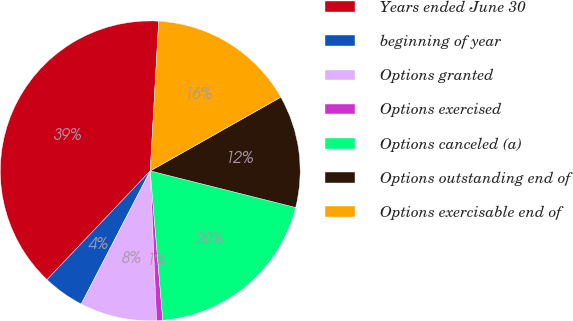Convert chart. <chart><loc_0><loc_0><loc_500><loc_500><pie_chart><fcel>Years ended June 30<fcel>beginning of year<fcel>Options granted<fcel>Options exercised<fcel>Options canceled (a)<fcel>Options outstanding end of<fcel>Options exercisable end of<nl><fcel>38.82%<fcel>4.47%<fcel>8.29%<fcel>0.66%<fcel>19.74%<fcel>12.11%<fcel>15.92%<nl></chart> 